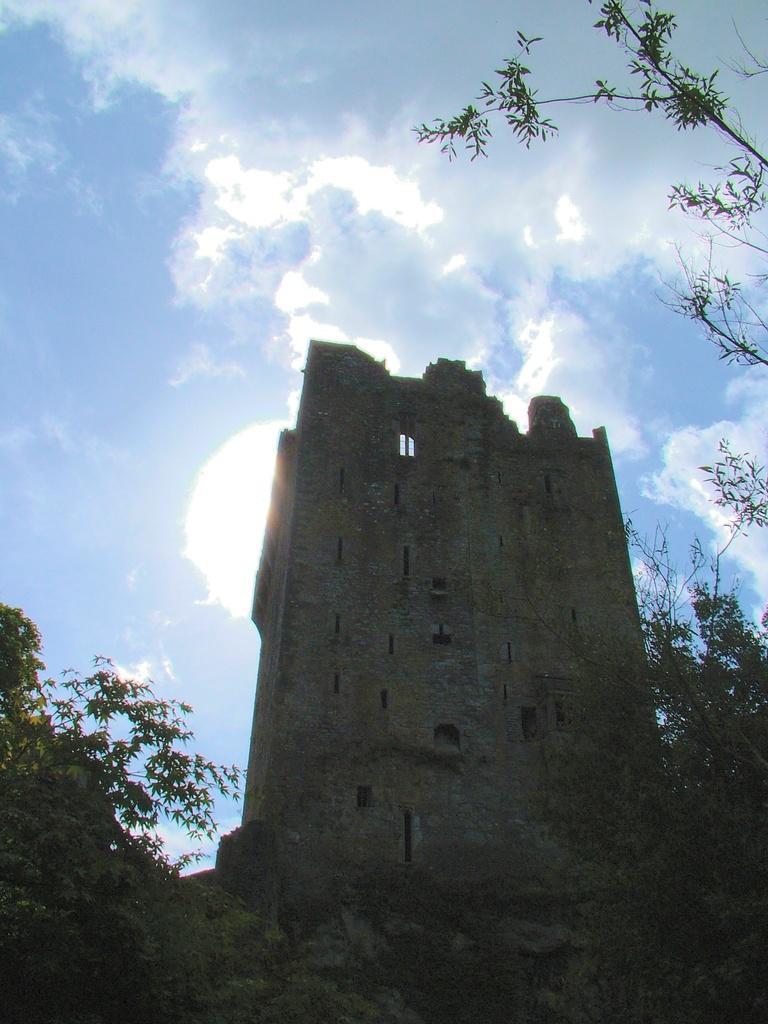Could you give a brief overview of what you see in this image? In this picture there is a monument. Beside that I can see the trees, plants and grass. In the background I can see the sky and clouds. 